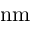<formula> <loc_0><loc_0><loc_500><loc_500>n m</formula> 